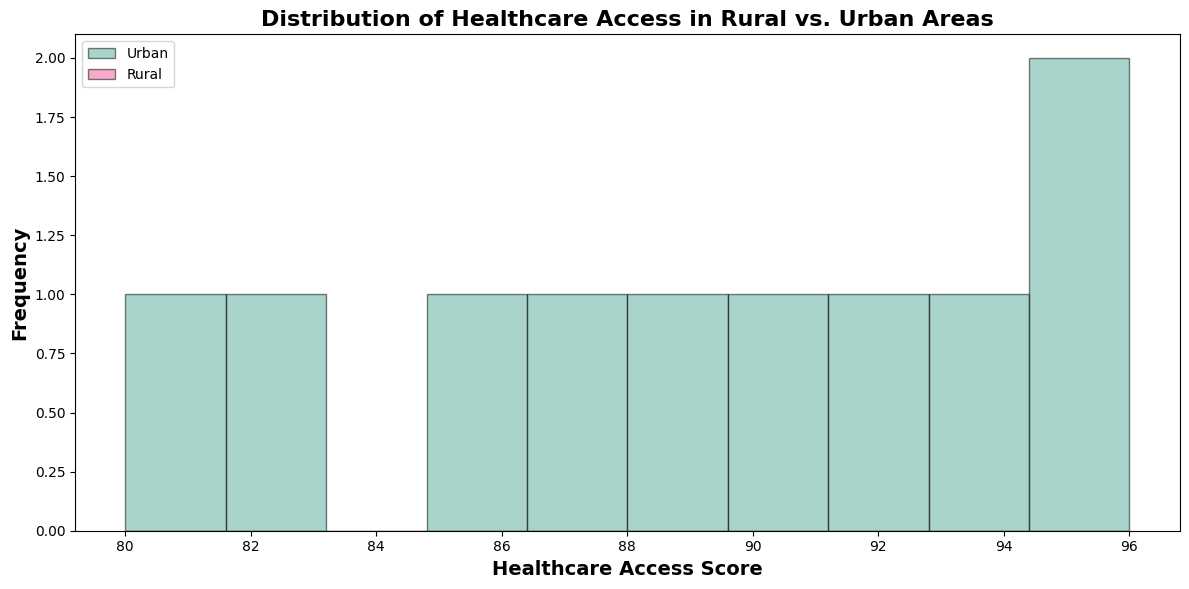what is the most frequent healthcare access score for urban areas? Look at the urban data histogram and identify which bar is the tallest, indicating it has the highest frequency.
Answer: 90 Which region has a higher overall healthcare access score? Compare the ranges of healthcare access scores on the histograms. Urban scores tend to range from 80 to 96, while rural scores range from 65 to 75, which are generally lower.
Answer: Urban What is the range of healthcare access scores in rural areas? Find the lowest and the highest score values in the rural histogram and subtract the lowest from the highest.
Answer: 10 Are there healthcare access scores that appear exclusively in one region? Check the bins of the histograms for scores that appear in either urban or rural areas but not both. Scores in the urban histogram do not appear in the rural histogram and vice versa.
Answer: Yes What is the difference between the highest healthcare access scores in urban and rural areas? Identify the highest scores in both histograms (96 for urban and 75 for rural) and subtract the rural score from the urban score.
Answer: 21 Which region shows more variability in healthcare access scores? Compare the spread of the bars in both histograms. The urban histogram has scores from 80 to 96, while the rural histogram ranges from 65 to 75, showing urban has a wider spread.
Answer: Urban 